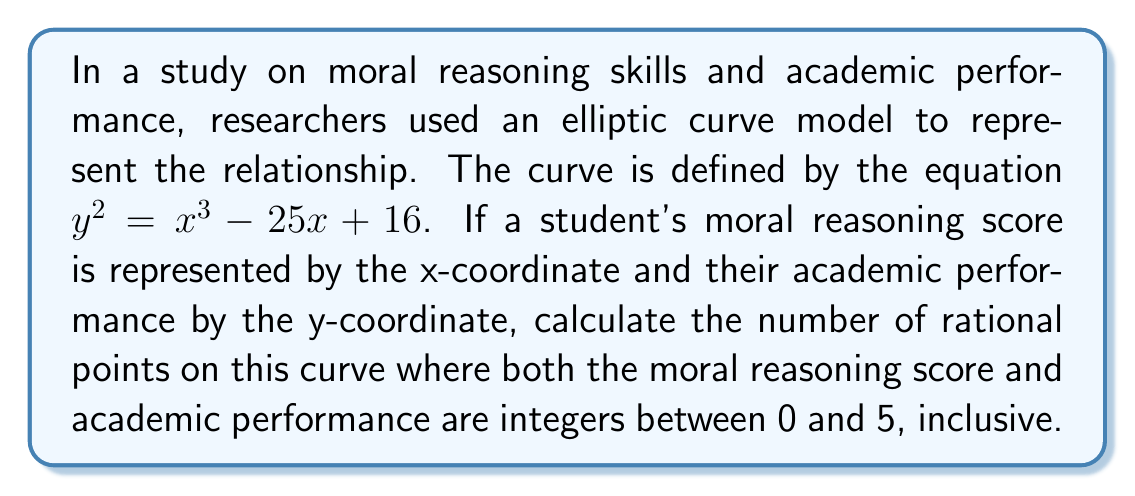Help me with this question. To solve this problem, we need to follow these steps:

1) The elliptic curve is given by $y^2 = x^3 - 25x + 16$

2) We need to check for integer solutions (x, y) where both x and y are between 0 and 5 inclusive.

3) Let's check each possible x value:

   For x = 0: $y^2 = 0^3 - 25(0) + 16 = 16$
              $y = \pm 4$
              (0, 4) is a valid point

   For x = 1: $y^2 = 1^3 - 25(1) + 16 = -8$
              No integer solution for y

   For x = 2: $y^2 = 2^3 - 25(2) + 16 = -42$
              No integer solution for y

   For x = 3: $y^2 = 3^3 - 25(3) + 16 = -46$
              No integer solution for y

   For x = 4: $y^2 = 4^3 - 25(4) + 16 = -16$
              No integer solution for y

   For x = 5: $y^2 = 5^3 - 25(5) + 16 = 16$
              $y = \pm 4$
              (5, 4) is a valid point

4) We found two points: (0, 4) and (5, 4)

5) However, we need to count (0, -4) and (5, -4) as well, as they also satisfy the equation and the constraints.

Therefore, there are 4 rational points on this curve where both coordinates are integers between 0 and 5, inclusive.
Answer: 4 